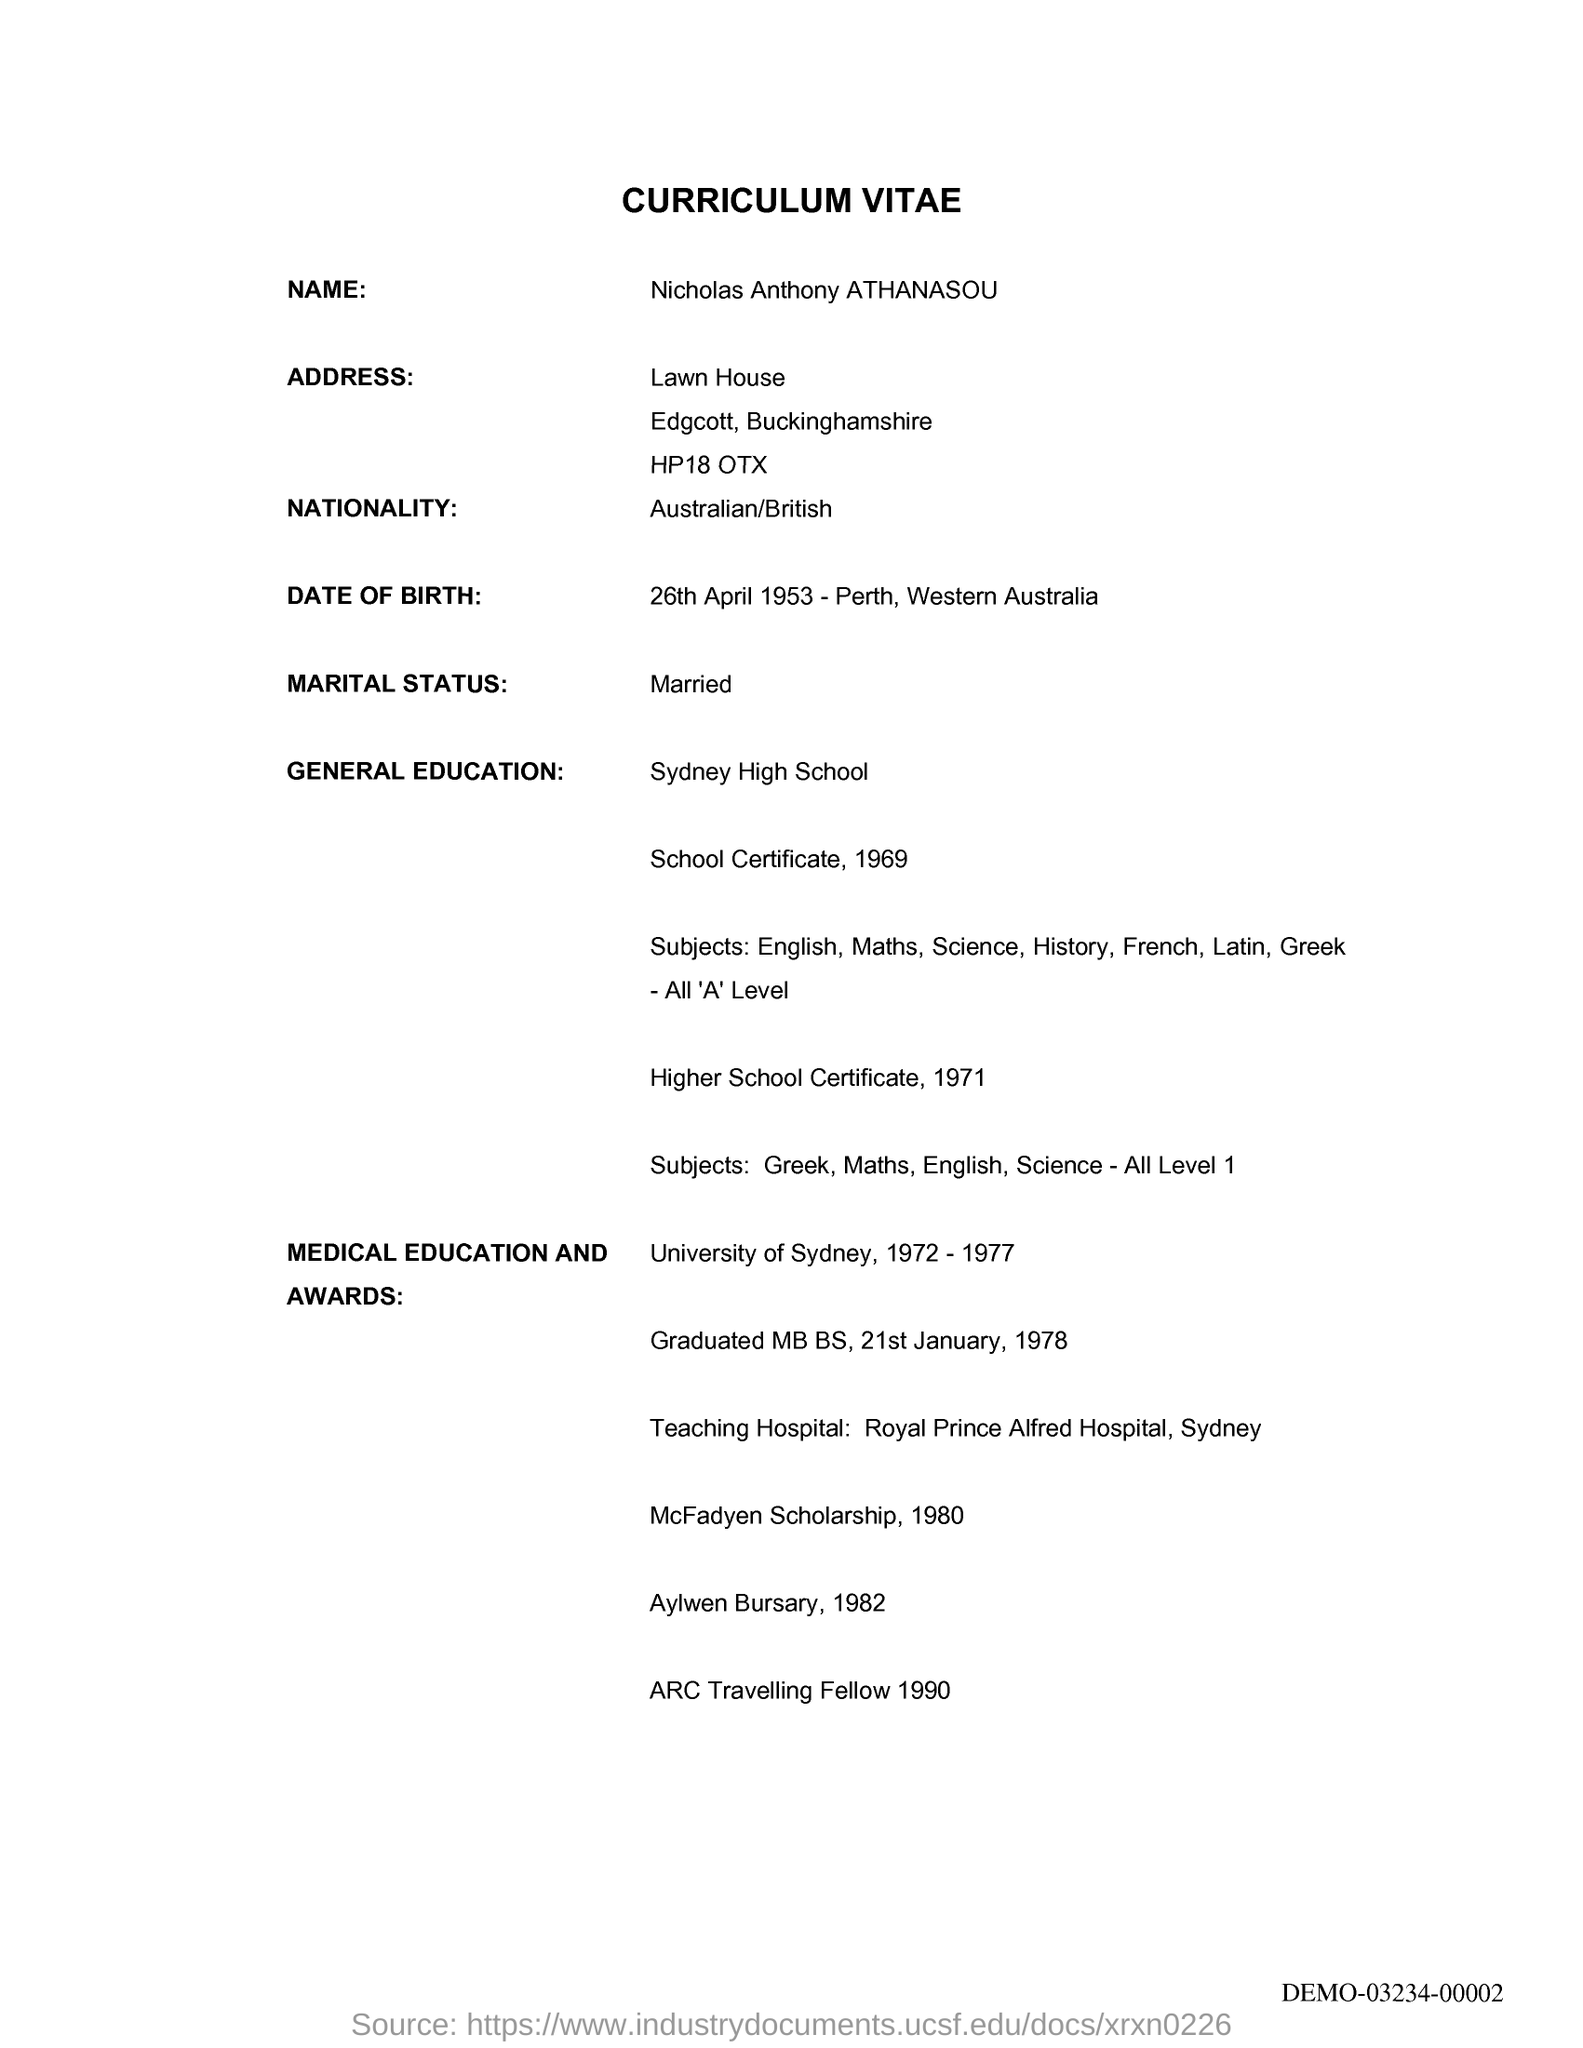Specify some key components in this picture. The applicant's date of birth is April 26, 1953. The applicant is Australian/British. The applicant's marital status is declared as "Married. The name of the candidate listed on the curriculum vitae is Nicholas Anthony ATHANASOU. 